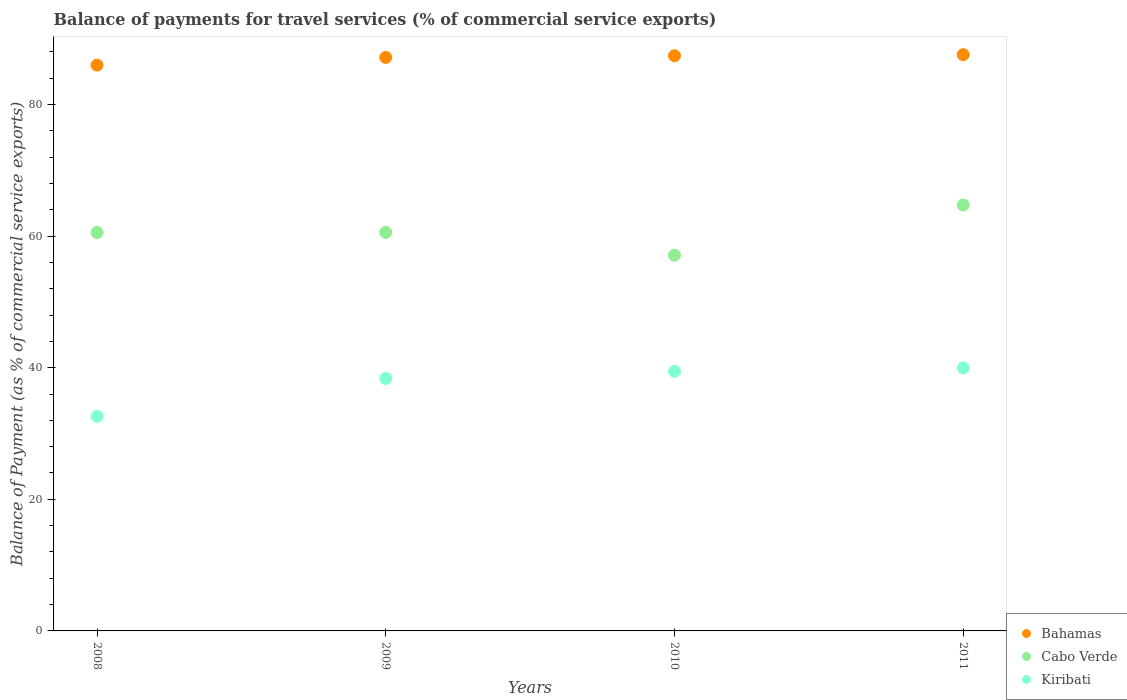Is the number of dotlines equal to the number of legend labels?
Provide a short and direct response. Yes. What is the balance of payments for travel services in Kiribati in 2010?
Provide a short and direct response. 39.45. Across all years, what is the maximum balance of payments for travel services in Cabo Verde?
Give a very brief answer. 64.72. Across all years, what is the minimum balance of payments for travel services in Cabo Verde?
Keep it short and to the point. 57.08. What is the total balance of payments for travel services in Bahamas in the graph?
Your answer should be compact. 348.1. What is the difference between the balance of payments for travel services in Kiribati in 2009 and that in 2010?
Offer a very short reply. -1.09. What is the difference between the balance of payments for travel services in Cabo Verde in 2011 and the balance of payments for travel services in Bahamas in 2008?
Offer a very short reply. -21.25. What is the average balance of payments for travel services in Kiribati per year?
Offer a very short reply. 37.6. In the year 2011, what is the difference between the balance of payments for travel services in Bahamas and balance of payments for travel services in Cabo Verde?
Provide a succinct answer. 22.84. In how many years, is the balance of payments for travel services in Cabo Verde greater than 4 %?
Your answer should be very brief. 4. What is the ratio of the balance of payments for travel services in Cabo Verde in 2008 to that in 2010?
Your response must be concise. 1.06. What is the difference between the highest and the second highest balance of payments for travel services in Kiribati?
Provide a succinct answer. 0.53. What is the difference between the highest and the lowest balance of payments for travel services in Cabo Verde?
Give a very brief answer. 7.64. Is the sum of the balance of payments for travel services in Kiribati in 2008 and 2009 greater than the maximum balance of payments for travel services in Bahamas across all years?
Provide a succinct answer. No. Is the balance of payments for travel services in Bahamas strictly less than the balance of payments for travel services in Cabo Verde over the years?
Your answer should be compact. No. How many years are there in the graph?
Ensure brevity in your answer.  4. What is the difference between two consecutive major ticks on the Y-axis?
Your answer should be compact. 20. Are the values on the major ticks of Y-axis written in scientific E-notation?
Ensure brevity in your answer.  No. What is the title of the graph?
Offer a terse response. Balance of payments for travel services (% of commercial service exports). What is the label or title of the Y-axis?
Offer a very short reply. Balance of Payment (as % of commercial service exports). What is the Balance of Payment (as % of commercial service exports) in Bahamas in 2008?
Your response must be concise. 85.98. What is the Balance of Payment (as % of commercial service exports) of Cabo Verde in 2008?
Offer a terse response. 60.55. What is the Balance of Payment (as % of commercial service exports) in Kiribati in 2008?
Ensure brevity in your answer.  32.61. What is the Balance of Payment (as % of commercial service exports) of Bahamas in 2009?
Your answer should be compact. 87.15. What is the Balance of Payment (as % of commercial service exports) of Cabo Verde in 2009?
Make the answer very short. 60.56. What is the Balance of Payment (as % of commercial service exports) in Kiribati in 2009?
Provide a short and direct response. 38.36. What is the Balance of Payment (as % of commercial service exports) of Bahamas in 2010?
Your answer should be compact. 87.4. What is the Balance of Payment (as % of commercial service exports) in Cabo Verde in 2010?
Make the answer very short. 57.08. What is the Balance of Payment (as % of commercial service exports) in Kiribati in 2010?
Provide a short and direct response. 39.45. What is the Balance of Payment (as % of commercial service exports) in Bahamas in 2011?
Provide a succinct answer. 87.57. What is the Balance of Payment (as % of commercial service exports) in Cabo Verde in 2011?
Your answer should be compact. 64.72. What is the Balance of Payment (as % of commercial service exports) in Kiribati in 2011?
Your answer should be compact. 39.97. Across all years, what is the maximum Balance of Payment (as % of commercial service exports) of Bahamas?
Your answer should be compact. 87.57. Across all years, what is the maximum Balance of Payment (as % of commercial service exports) of Cabo Verde?
Your answer should be compact. 64.72. Across all years, what is the maximum Balance of Payment (as % of commercial service exports) of Kiribati?
Make the answer very short. 39.97. Across all years, what is the minimum Balance of Payment (as % of commercial service exports) of Bahamas?
Your answer should be very brief. 85.98. Across all years, what is the minimum Balance of Payment (as % of commercial service exports) in Cabo Verde?
Provide a short and direct response. 57.08. Across all years, what is the minimum Balance of Payment (as % of commercial service exports) in Kiribati?
Offer a terse response. 32.61. What is the total Balance of Payment (as % of commercial service exports) in Bahamas in the graph?
Offer a very short reply. 348.1. What is the total Balance of Payment (as % of commercial service exports) of Cabo Verde in the graph?
Offer a terse response. 242.92. What is the total Balance of Payment (as % of commercial service exports) in Kiribati in the graph?
Offer a terse response. 150.38. What is the difference between the Balance of Payment (as % of commercial service exports) of Bahamas in 2008 and that in 2009?
Ensure brevity in your answer.  -1.17. What is the difference between the Balance of Payment (as % of commercial service exports) of Cabo Verde in 2008 and that in 2009?
Ensure brevity in your answer.  -0.02. What is the difference between the Balance of Payment (as % of commercial service exports) in Kiribati in 2008 and that in 2009?
Offer a very short reply. -5.75. What is the difference between the Balance of Payment (as % of commercial service exports) in Bahamas in 2008 and that in 2010?
Make the answer very short. -1.43. What is the difference between the Balance of Payment (as % of commercial service exports) of Cabo Verde in 2008 and that in 2010?
Provide a short and direct response. 3.46. What is the difference between the Balance of Payment (as % of commercial service exports) of Kiribati in 2008 and that in 2010?
Offer a very short reply. -6.84. What is the difference between the Balance of Payment (as % of commercial service exports) in Bahamas in 2008 and that in 2011?
Provide a succinct answer. -1.59. What is the difference between the Balance of Payment (as % of commercial service exports) in Cabo Verde in 2008 and that in 2011?
Provide a succinct answer. -4.18. What is the difference between the Balance of Payment (as % of commercial service exports) in Kiribati in 2008 and that in 2011?
Your answer should be very brief. -7.37. What is the difference between the Balance of Payment (as % of commercial service exports) of Bahamas in 2009 and that in 2010?
Make the answer very short. -0.26. What is the difference between the Balance of Payment (as % of commercial service exports) of Cabo Verde in 2009 and that in 2010?
Provide a succinct answer. 3.48. What is the difference between the Balance of Payment (as % of commercial service exports) of Kiribati in 2009 and that in 2010?
Your response must be concise. -1.09. What is the difference between the Balance of Payment (as % of commercial service exports) in Bahamas in 2009 and that in 2011?
Your response must be concise. -0.42. What is the difference between the Balance of Payment (as % of commercial service exports) of Cabo Verde in 2009 and that in 2011?
Your response must be concise. -4.16. What is the difference between the Balance of Payment (as % of commercial service exports) in Kiribati in 2009 and that in 2011?
Ensure brevity in your answer.  -1.61. What is the difference between the Balance of Payment (as % of commercial service exports) of Bahamas in 2010 and that in 2011?
Keep it short and to the point. -0.16. What is the difference between the Balance of Payment (as % of commercial service exports) of Cabo Verde in 2010 and that in 2011?
Your answer should be very brief. -7.64. What is the difference between the Balance of Payment (as % of commercial service exports) of Kiribati in 2010 and that in 2011?
Make the answer very short. -0.53. What is the difference between the Balance of Payment (as % of commercial service exports) in Bahamas in 2008 and the Balance of Payment (as % of commercial service exports) in Cabo Verde in 2009?
Offer a very short reply. 25.42. What is the difference between the Balance of Payment (as % of commercial service exports) in Bahamas in 2008 and the Balance of Payment (as % of commercial service exports) in Kiribati in 2009?
Offer a terse response. 47.62. What is the difference between the Balance of Payment (as % of commercial service exports) in Cabo Verde in 2008 and the Balance of Payment (as % of commercial service exports) in Kiribati in 2009?
Offer a very short reply. 22.19. What is the difference between the Balance of Payment (as % of commercial service exports) of Bahamas in 2008 and the Balance of Payment (as % of commercial service exports) of Cabo Verde in 2010?
Give a very brief answer. 28.89. What is the difference between the Balance of Payment (as % of commercial service exports) in Bahamas in 2008 and the Balance of Payment (as % of commercial service exports) in Kiribati in 2010?
Provide a short and direct response. 46.53. What is the difference between the Balance of Payment (as % of commercial service exports) of Cabo Verde in 2008 and the Balance of Payment (as % of commercial service exports) of Kiribati in 2010?
Provide a short and direct response. 21.1. What is the difference between the Balance of Payment (as % of commercial service exports) of Bahamas in 2008 and the Balance of Payment (as % of commercial service exports) of Cabo Verde in 2011?
Your answer should be compact. 21.25. What is the difference between the Balance of Payment (as % of commercial service exports) in Bahamas in 2008 and the Balance of Payment (as % of commercial service exports) in Kiribati in 2011?
Your response must be concise. 46.01. What is the difference between the Balance of Payment (as % of commercial service exports) of Cabo Verde in 2008 and the Balance of Payment (as % of commercial service exports) of Kiribati in 2011?
Offer a very short reply. 20.57. What is the difference between the Balance of Payment (as % of commercial service exports) of Bahamas in 2009 and the Balance of Payment (as % of commercial service exports) of Cabo Verde in 2010?
Your response must be concise. 30.06. What is the difference between the Balance of Payment (as % of commercial service exports) in Bahamas in 2009 and the Balance of Payment (as % of commercial service exports) in Kiribati in 2010?
Give a very brief answer. 47.7. What is the difference between the Balance of Payment (as % of commercial service exports) of Cabo Verde in 2009 and the Balance of Payment (as % of commercial service exports) of Kiribati in 2010?
Make the answer very short. 21.12. What is the difference between the Balance of Payment (as % of commercial service exports) in Bahamas in 2009 and the Balance of Payment (as % of commercial service exports) in Cabo Verde in 2011?
Offer a very short reply. 22.42. What is the difference between the Balance of Payment (as % of commercial service exports) of Bahamas in 2009 and the Balance of Payment (as % of commercial service exports) of Kiribati in 2011?
Your answer should be compact. 47.17. What is the difference between the Balance of Payment (as % of commercial service exports) of Cabo Verde in 2009 and the Balance of Payment (as % of commercial service exports) of Kiribati in 2011?
Provide a short and direct response. 20.59. What is the difference between the Balance of Payment (as % of commercial service exports) in Bahamas in 2010 and the Balance of Payment (as % of commercial service exports) in Cabo Verde in 2011?
Your answer should be very brief. 22.68. What is the difference between the Balance of Payment (as % of commercial service exports) in Bahamas in 2010 and the Balance of Payment (as % of commercial service exports) in Kiribati in 2011?
Offer a terse response. 47.43. What is the difference between the Balance of Payment (as % of commercial service exports) of Cabo Verde in 2010 and the Balance of Payment (as % of commercial service exports) of Kiribati in 2011?
Offer a terse response. 17.11. What is the average Balance of Payment (as % of commercial service exports) in Bahamas per year?
Your answer should be compact. 87.02. What is the average Balance of Payment (as % of commercial service exports) in Cabo Verde per year?
Offer a very short reply. 60.73. What is the average Balance of Payment (as % of commercial service exports) in Kiribati per year?
Your answer should be compact. 37.6. In the year 2008, what is the difference between the Balance of Payment (as % of commercial service exports) in Bahamas and Balance of Payment (as % of commercial service exports) in Cabo Verde?
Your answer should be compact. 25.43. In the year 2008, what is the difference between the Balance of Payment (as % of commercial service exports) of Bahamas and Balance of Payment (as % of commercial service exports) of Kiribati?
Your answer should be compact. 53.37. In the year 2008, what is the difference between the Balance of Payment (as % of commercial service exports) in Cabo Verde and Balance of Payment (as % of commercial service exports) in Kiribati?
Provide a short and direct response. 27.94. In the year 2009, what is the difference between the Balance of Payment (as % of commercial service exports) of Bahamas and Balance of Payment (as % of commercial service exports) of Cabo Verde?
Offer a terse response. 26.58. In the year 2009, what is the difference between the Balance of Payment (as % of commercial service exports) of Bahamas and Balance of Payment (as % of commercial service exports) of Kiribati?
Your answer should be compact. 48.79. In the year 2009, what is the difference between the Balance of Payment (as % of commercial service exports) of Cabo Verde and Balance of Payment (as % of commercial service exports) of Kiribati?
Give a very brief answer. 22.2. In the year 2010, what is the difference between the Balance of Payment (as % of commercial service exports) in Bahamas and Balance of Payment (as % of commercial service exports) in Cabo Verde?
Provide a succinct answer. 30.32. In the year 2010, what is the difference between the Balance of Payment (as % of commercial service exports) of Bahamas and Balance of Payment (as % of commercial service exports) of Kiribati?
Provide a short and direct response. 47.96. In the year 2010, what is the difference between the Balance of Payment (as % of commercial service exports) in Cabo Verde and Balance of Payment (as % of commercial service exports) in Kiribati?
Your answer should be compact. 17.64. In the year 2011, what is the difference between the Balance of Payment (as % of commercial service exports) of Bahamas and Balance of Payment (as % of commercial service exports) of Cabo Verde?
Offer a very short reply. 22.84. In the year 2011, what is the difference between the Balance of Payment (as % of commercial service exports) in Bahamas and Balance of Payment (as % of commercial service exports) in Kiribati?
Your response must be concise. 47.59. In the year 2011, what is the difference between the Balance of Payment (as % of commercial service exports) in Cabo Verde and Balance of Payment (as % of commercial service exports) in Kiribati?
Give a very brief answer. 24.75. What is the ratio of the Balance of Payment (as % of commercial service exports) in Bahamas in 2008 to that in 2009?
Give a very brief answer. 0.99. What is the ratio of the Balance of Payment (as % of commercial service exports) in Kiribati in 2008 to that in 2009?
Your answer should be compact. 0.85. What is the ratio of the Balance of Payment (as % of commercial service exports) of Bahamas in 2008 to that in 2010?
Offer a terse response. 0.98. What is the ratio of the Balance of Payment (as % of commercial service exports) of Cabo Verde in 2008 to that in 2010?
Your response must be concise. 1.06. What is the ratio of the Balance of Payment (as % of commercial service exports) in Kiribati in 2008 to that in 2010?
Your answer should be compact. 0.83. What is the ratio of the Balance of Payment (as % of commercial service exports) in Bahamas in 2008 to that in 2011?
Make the answer very short. 0.98. What is the ratio of the Balance of Payment (as % of commercial service exports) in Cabo Verde in 2008 to that in 2011?
Provide a succinct answer. 0.94. What is the ratio of the Balance of Payment (as % of commercial service exports) in Kiribati in 2008 to that in 2011?
Keep it short and to the point. 0.82. What is the ratio of the Balance of Payment (as % of commercial service exports) of Cabo Verde in 2009 to that in 2010?
Your response must be concise. 1.06. What is the ratio of the Balance of Payment (as % of commercial service exports) of Kiribati in 2009 to that in 2010?
Give a very brief answer. 0.97. What is the ratio of the Balance of Payment (as % of commercial service exports) in Bahamas in 2009 to that in 2011?
Your answer should be very brief. 1. What is the ratio of the Balance of Payment (as % of commercial service exports) in Cabo Verde in 2009 to that in 2011?
Your answer should be compact. 0.94. What is the ratio of the Balance of Payment (as % of commercial service exports) in Kiribati in 2009 to that in 2011?
Your answer should be compact. 0.96. What is the ratio of the Balance of Payment (as % of commercial service exports) in Bahamas in 2010 to that in 2011?
Keep it short and to the point. 1. What is the ratio of the Balance of Payment (as % of commercial service exports) of Cabo Verde in 2010 to that in 2011?
Provide a short and direct response. 0.88. What is the difference between the highest and the second highest Balance of Payment (as % of commercial service exports) of Bahamas?
Provide a short and direct response. 0.16. What is the difference between the highest and the second highest Balance of Payment (as % of commercial service exports) of Cabo Verde?
Offer a very short reply. 4.16. What is the difference between the highest and the second highest Balance of Payment (as % of commercial service exports) in Kiribati?
Your response must be concise. 0.53. What is the difference between the highest and the lowest Balance of Payment (as % of commercial service exports) in Bahamas?
Offer a terse response. 1.59. What is the difference between the highest and the lowest Balance of Payment (as % of commercial service exports) of Cabo Verde?
Make the answer very short. 7.64. What is the difference between the highest and the lowest Balance of Payment (as % of commercial service exports) of Kiribati?
Ensure brevity in your answer.  7.37. 